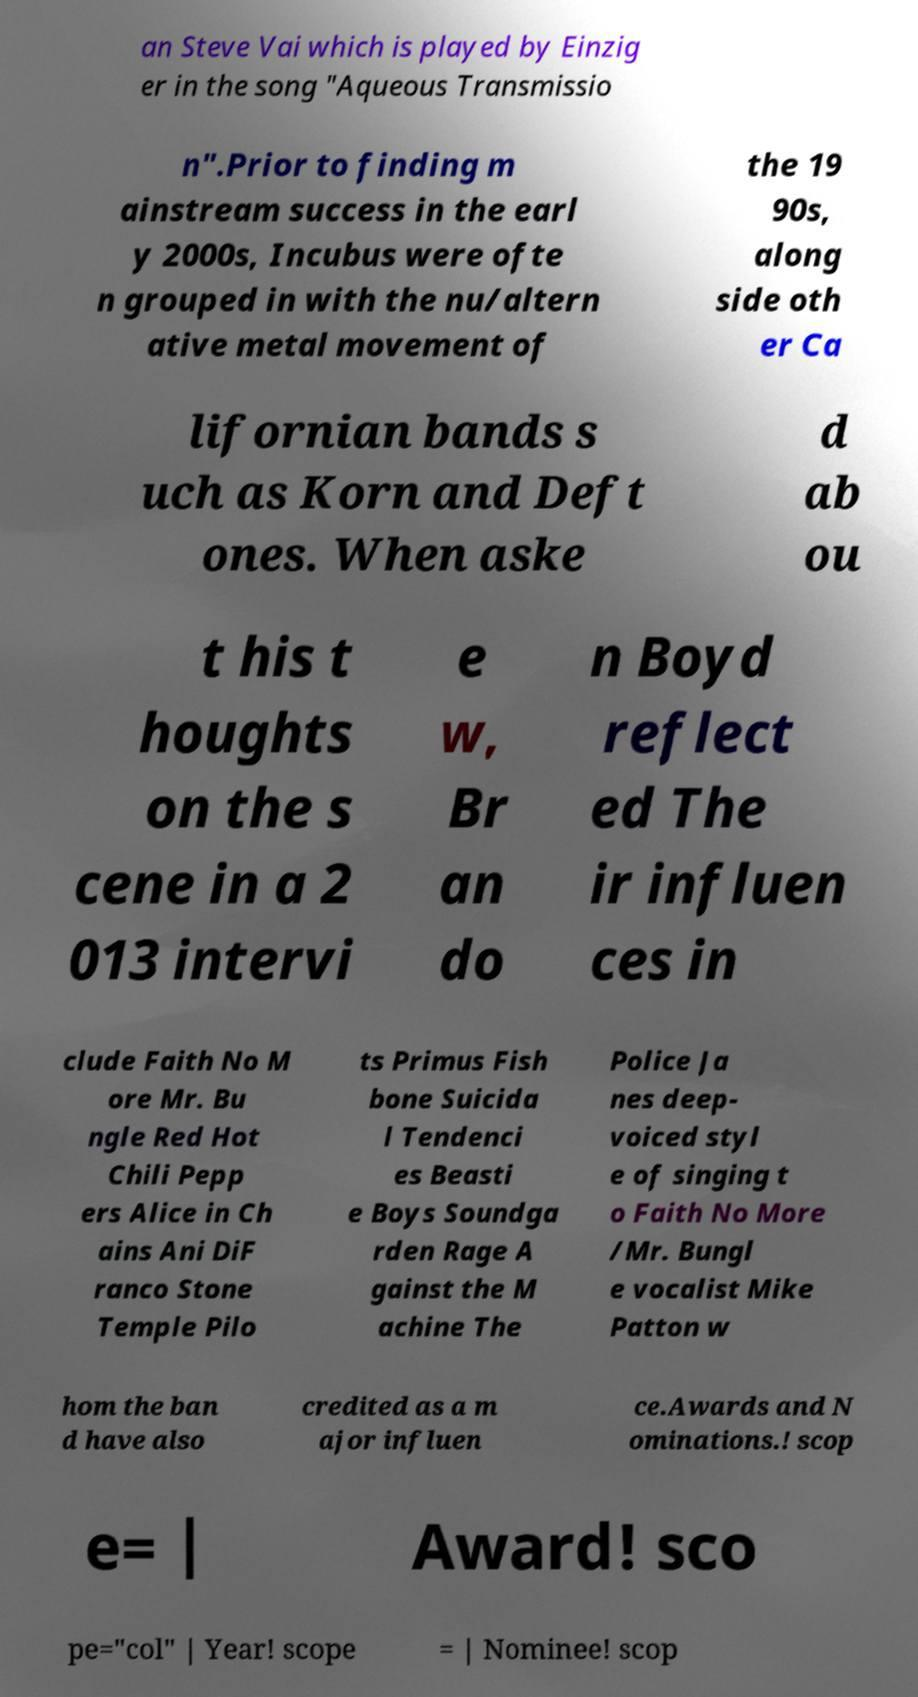For documentation purposes, I need the text within this image transcribed. Could you provide that? an Steve Vai which is played by Einzig er in the song "Aqueous Transmissio n".Prior to finding m ainstream success in the earl y 2000s, Incubus were ofte n grouped in with the nu/altern ative metal movement of the 19 90s, along side oth er Ca lifornian bands s uch as Korn and Deft ones. When aske d ab ou t his t houghts on the s cene in a 2 013 intervi e w, Br an do n Boyd reflect ed The ir influen ces in clude Faith No M ore Mr. Bu ngle Red Hot Chili Pepp ers Alice in Ch ains Ani DiF ranco Stone Temple Pilo ts Primus Fish bone Suicida l Tendenci es Beasti e Boys Soundga rden Rage A gainst the M achine The Police Ja nes deep- voiced styl e of singing t o Faith No More /Mr. Bungl e vocalist Mike Patton w hom the ban d have also credited as a m ajor influen ce.Awards and N ominations.! scop e= | Award! sco pe="col" | Year! scope = | Nominee! scop 